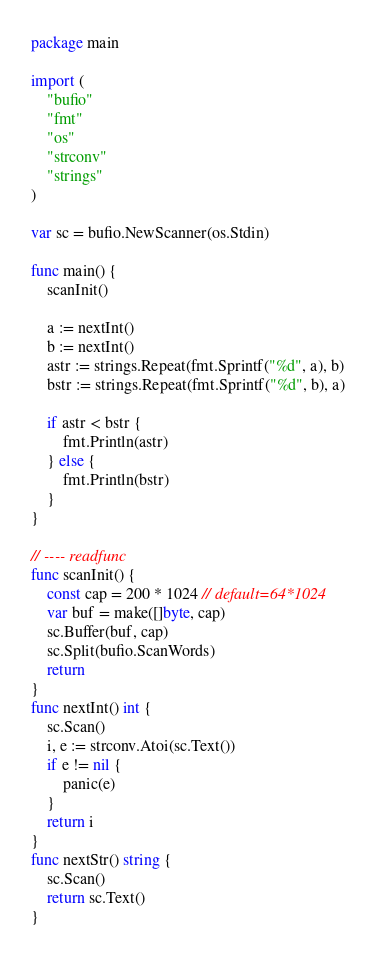Convert code to text. <code><loc_0><loc_0><loc_500><loc_500><_Go_>package main

import (
	"bufio"
	"fmt"
	"os"
	"strconv"
	"strings"
)

var sc = bufio.NewScanner(os.Stdin)

func main() {
	scanInit()

	a := nextInt()
	b := nextInt()
	astr := strings.Repeat(fmt.Sprintf("%d", a), b)
	bstr := strings.Repeat(fmt.Sprintf("%d", b), a)

	if astr < bstr {
		fmt.Println(astr)
	} else {
		fmt.Println(bstr)
	}
}

// ---- readfunc
func scanInit() {
	const cap = 200 * 1024 // default=64*1024
	var buf = make([]byte, cap)
	sc.Buffer(buf, cap)
	sc.Split(bufio.ScanWords)
	return
}
func nextInt() int {
	sc.Scan()
	i, e := strconv.Atoi(sc.Text())
	if e != nil {
		panic(e)
	}
	return i
}
func nextStr() string {
	sc.Scan()
	return sc.Text()
}
</code> 